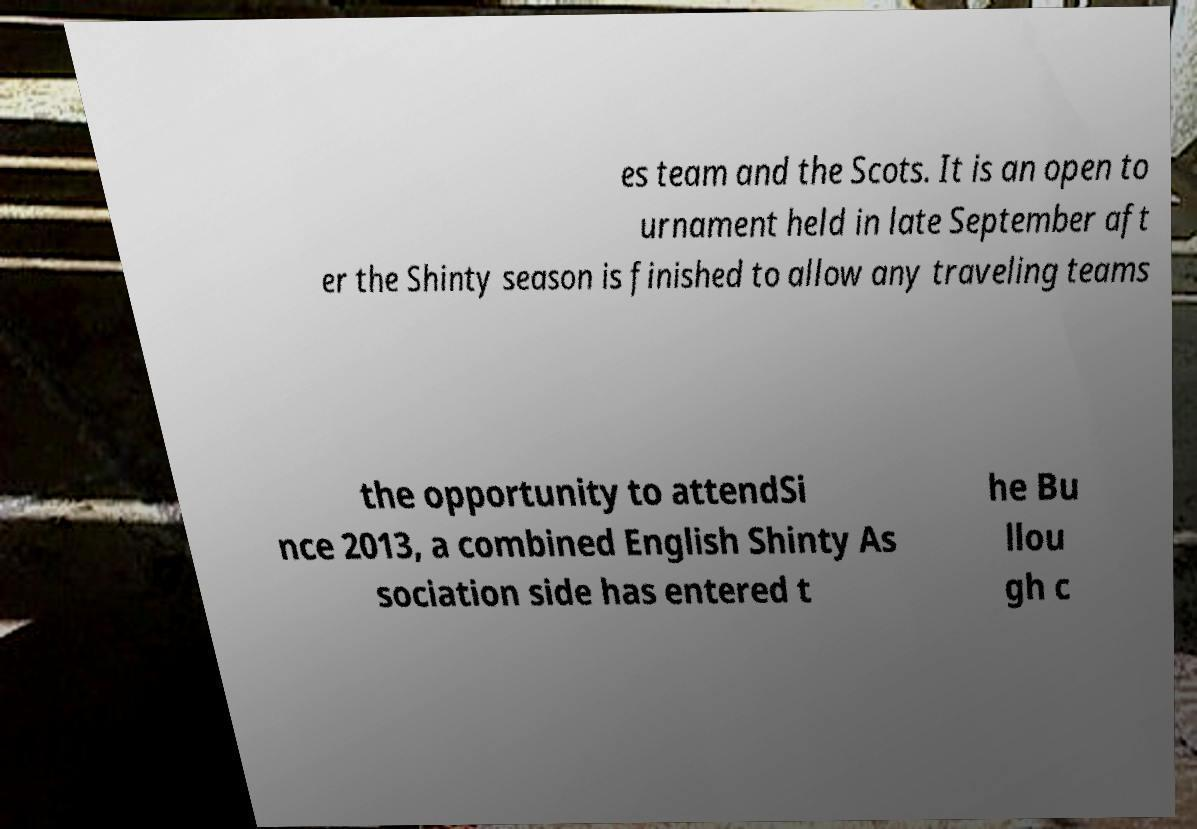Please identify and transcribe the text found in this image. es team and the Scots. It is an open to urnament held in late September aft er the Shinty season is finished to allow any traveling teams the opportunity to attendSi nce 2013, a combined English Shinty As sociation side has entered t he Bu llou gh c 